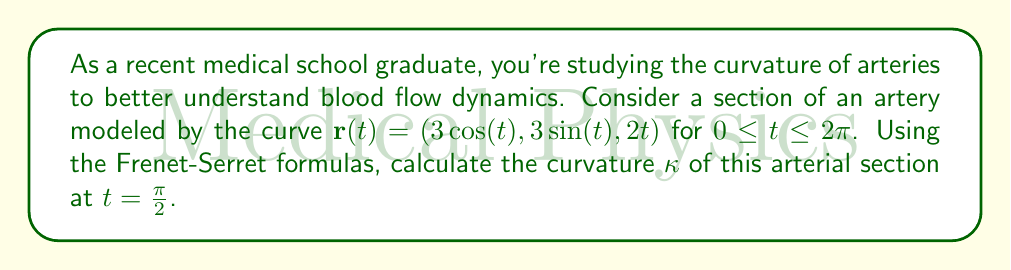Can you solve this math problem? Let's approach this step-by-step using the Frenet-Serret formulas:

1) First, we need to calculate $\mathbf{r}'(t)$ and $\mathbf{r}''(t)$:

   $\mathbf{r}'(t) = (-3\sin(t), 3\cos(t), 2)$
   $\mathbf{r}''(t) = (-3\cos(t), -3\sin(t), 0)$

2) The curvature $\kappa$ is given by:

   $$\kappa = \frac{|\mathbf{r}'(t) \times \mathbf{r}''(t)|}{|\mathbf{r}'(t)|^3}$$

3) Let's calculate $\mathbf{r}'(t) \times \mathbf{r}''(t)$:

   $$\begin{vmatrix} 
   \mathbf{i} & \mathbf{j} & \mathbf{k} \\
   -3\sin(t) & 3\cos(t) & 2 \\
   -3\cos(t) & -3\sin(t) & 0
   \end{vmatrix}$$

   $= (6\sin(t), -6\cos(t), 9\sin^2(t) + 9\cos^2(t))$
   $= (6\sin(t), -6\cos(t), 9)$

4) The magnitude of this cross product is:

   $|\mathbf{r}'(t) \times \mathbf{r}''(t)| = \sqrt{36\sin^2(t) + 36\cos^2(t) + 81} = \sqrt{117}$

5) Now, let's calculate $|\mathbf{r}'(t)|$:

   $|\mathbf{r}'(t)| = \sqrt{9\sin^2(t) + 9\cos^2(t) + 4} = \sqrt{13}$

6) Therefore, the curvature is:

   $$\kappa = \frac{\sqrt{117}}{(\sqrt{13})^3} = \frac{\sqrt{117}}{13\sqrt{13}}$$

7) This expression is constant for all $t$, including $t = \frac{\pi}{2}$.
Answer: $\frac{\sqrt{117}}{13\sqrt{13}}$ 